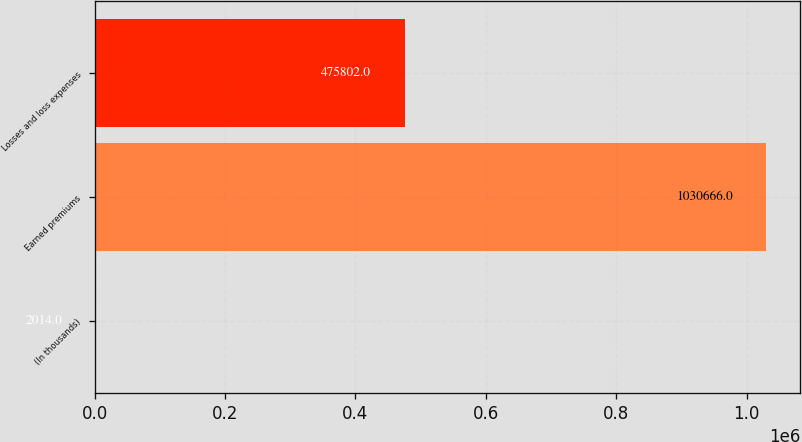Convert chart. <chart><loc_0><loc_0><loc_500><loc_500><bar_chart><fcel>(In thousands)<fcel>Earned premiums<fcel>Losses and loss expenses<nl><fcel>2014<fcel>1.03067e+06<fcel>475802<nl></chart> 